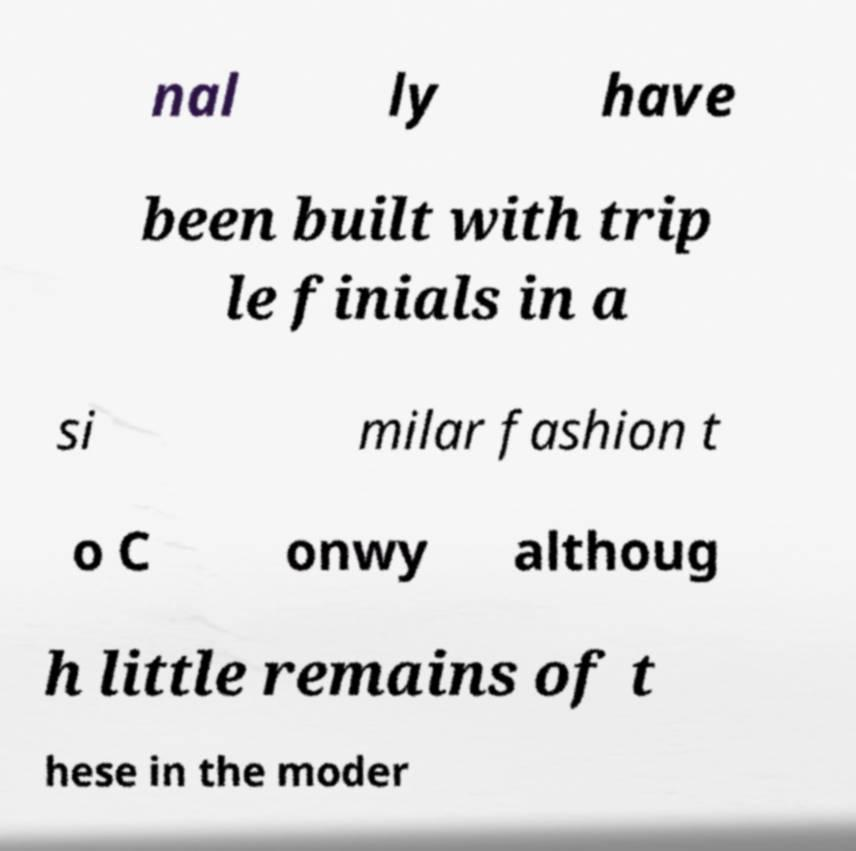For documentation purposes, I need the text within this image transcribed. Could you provide that? nal ly have been built with trip le finials in a si milar fashion t o C onwy althoug h little remains of t hese in the moder 